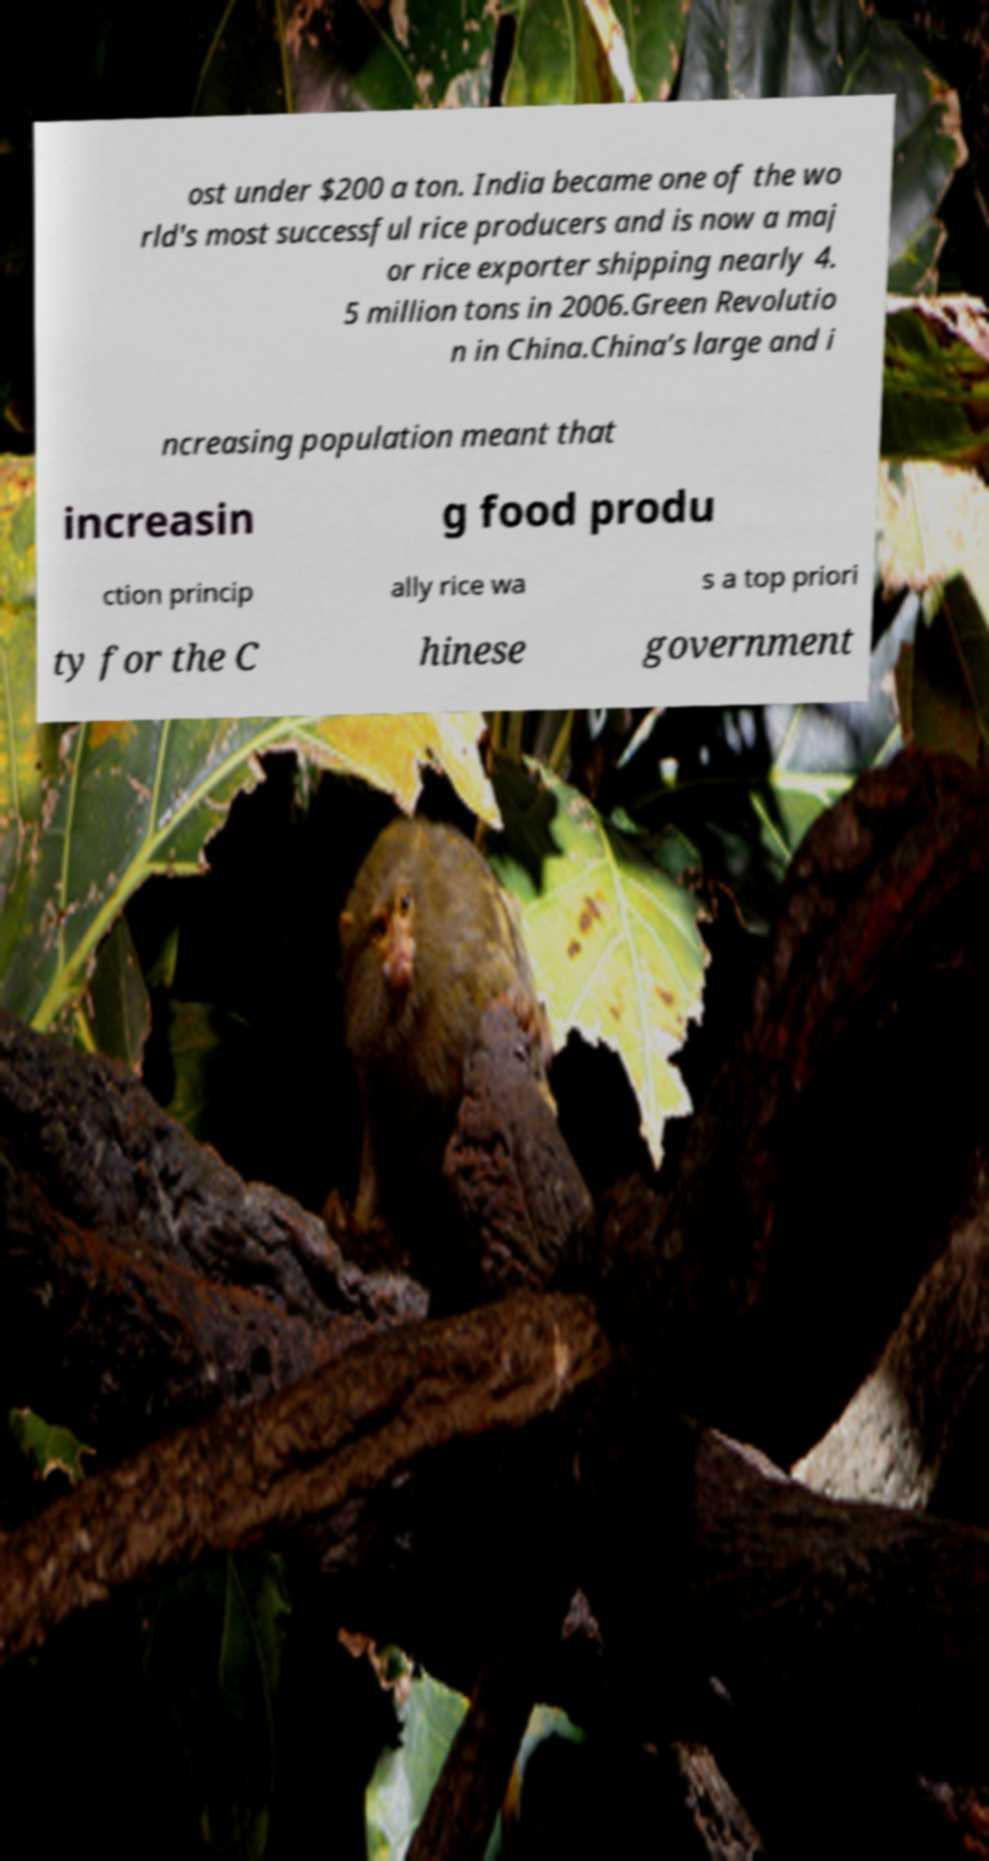Can you read and provide the text displayed in the image?This photo seems to have some interesting text. Can you extract and type it out for me? ost under $200 a ton. India became one of the wo rld's most successful rice producers and is now a maj or rice exporter shipping nearly 4. 5 million tons in 2006.Green Revolutio n in China.China’s large and i ncreasing population meant that increasin g food produ ction princip ally rice wa s a top priori ty for the C hinese government 